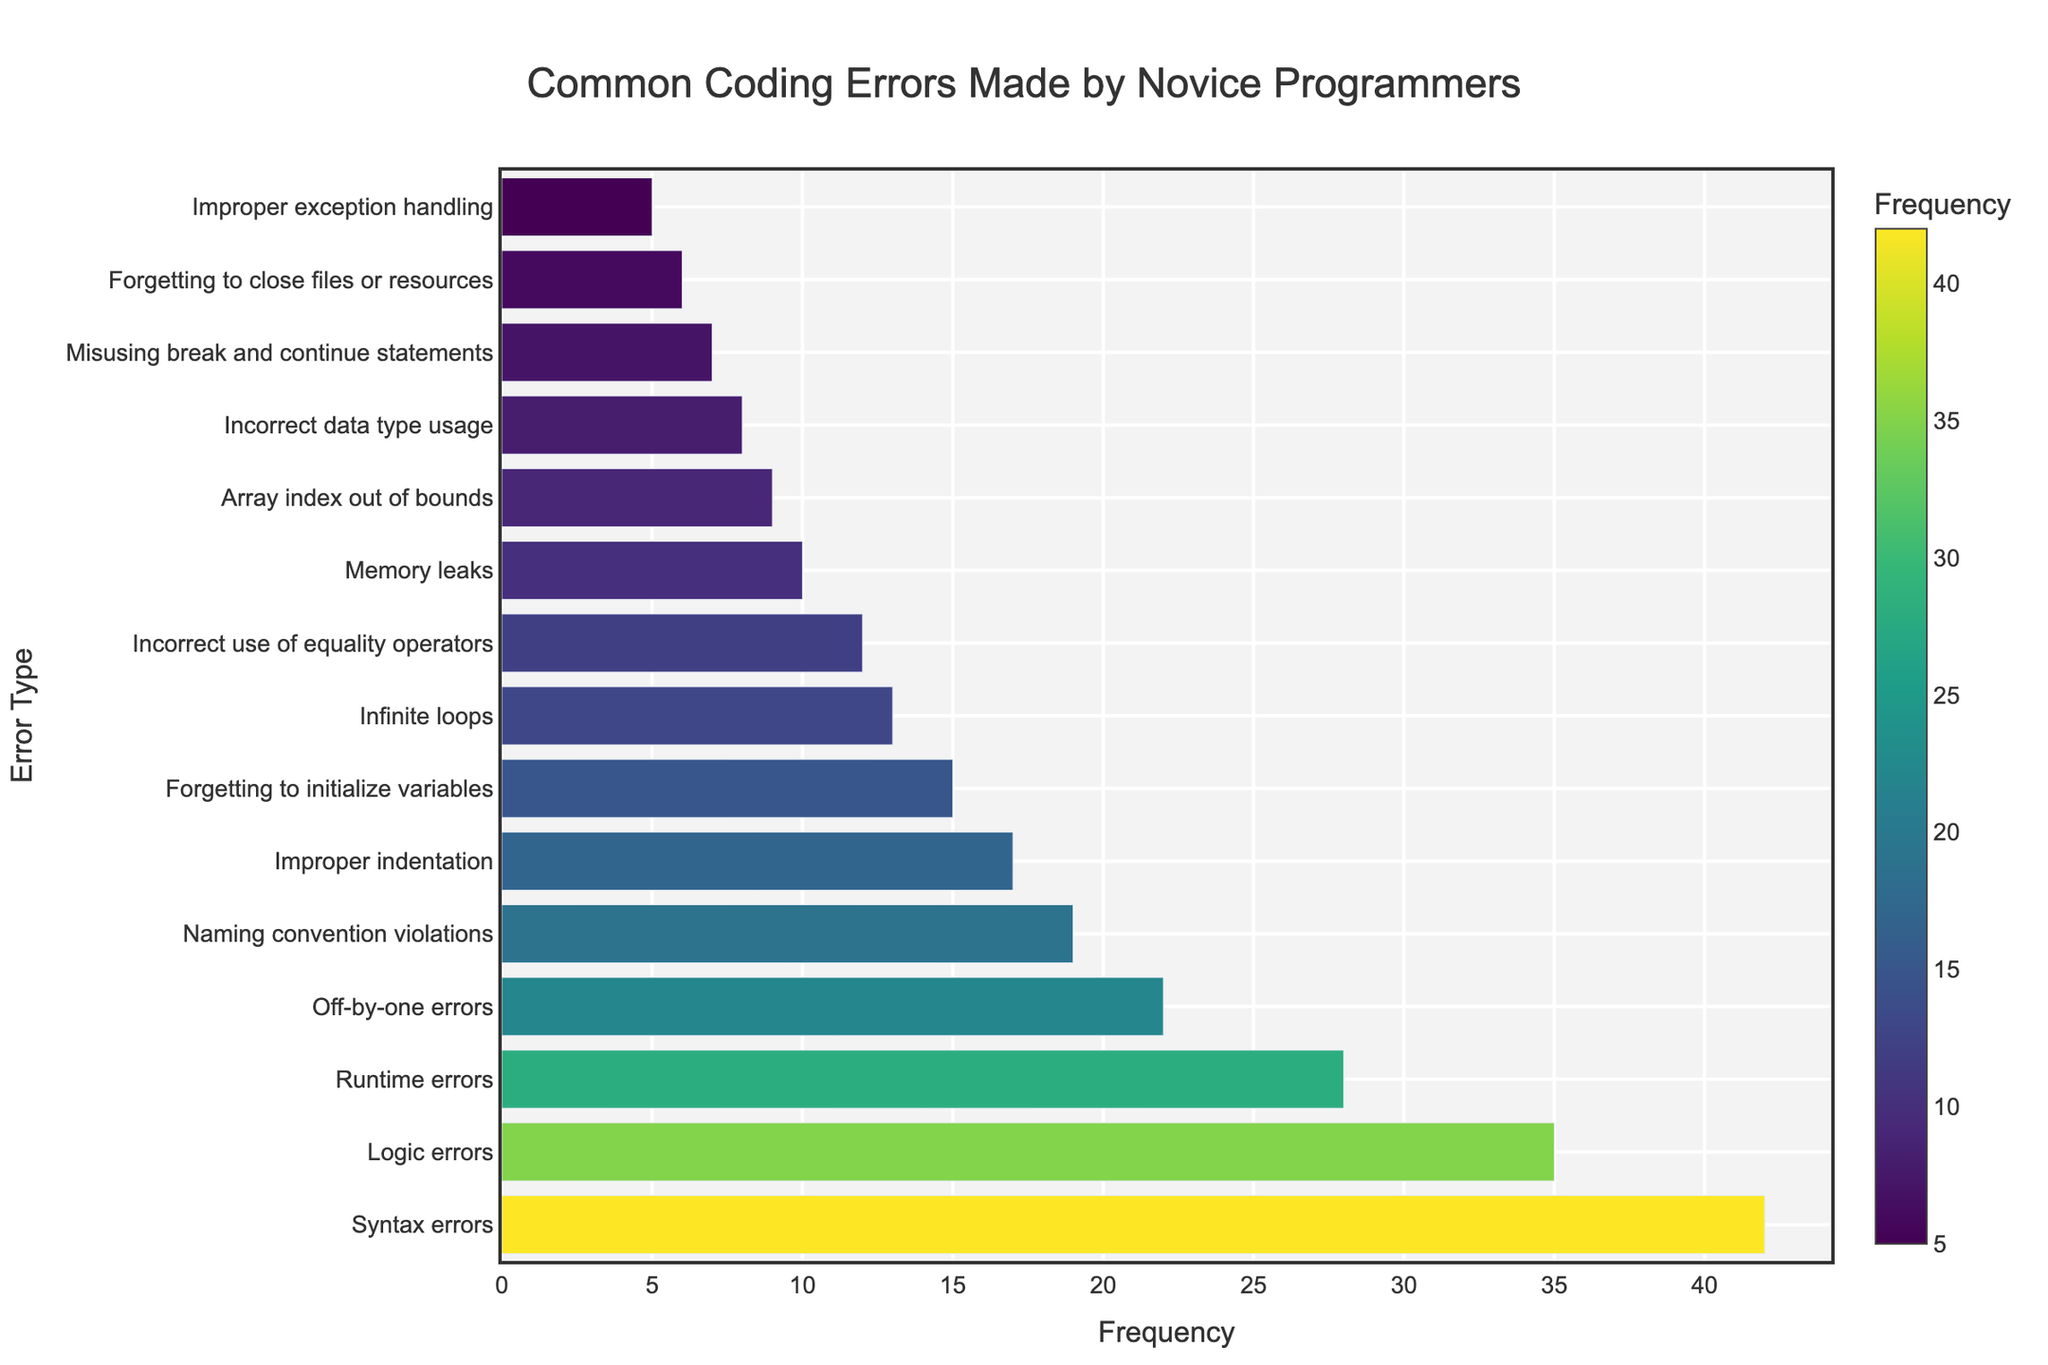What is the most common coding error made by novice programmers? The figure shows a bar chart listing different types of coding errors along with their frequencies. The longest bar represents the most common error, which is "Syntax errors" with a frequency of 42.
Answer: Syntax errors Which coding error has a lower frequency than "Runtime errors" but higher than "Naming convention violations"? The figure shows that "Off-by-one errors" has a frequency of 22, which is lower than "Runtime errors" (28) but higher than "Naming convention violations" (19).
Answer: Off-by-one errors What is the sum of the frequencies for "Logic errors" and "Improper indentation"? "Logic errors" have a frequency of 35 and "Improper indentation" has a frequency of 17. Adding these gives us 35 + 17 = 52.
Answer: 52 How much more frequent are "Syntax errors" compared to "Memory leaks"? "Syntax errors" have a frequency of 42 and "Memory leaks" have a frequency of 10. Subtracting these gives us 42 - 10 = 32.
Answer: 32 Are "Array index out of bounds" errors more or less common than "Infinite loops"? The frequency for "Array index out of bounds" is 9, while "Infinite loops" is 13. Therefore, "Array index out of bounds" errors are less common than "Infinite loops."
Answer: Less What is the average frequency of the errors that have more than 20 occurrences? Errors with frequencies greater than 20 are "Syntax errors" (42), "Logic errors" (35), "Runtime errors" (28), and "Off-by-one errors" (22). Sum these to get 42 + 35 + 28 + 22 = 127. There are 4 errors, so the average is 127 / 4 = 31.75.
Answer: 31.75 Which errors share the same color shading on the bar chart? The color shading represents similar frequency values. "Improper indentation" (17) and "Forgetting to initialize variables" (15) are close in frequency and would appear in similar color shading.
Answer: Improper indentation and Forgetting to initialize variables How many error types have frequencies under 10? Looking at the frequencies: "Array index out of bounds" (9), "Incorrect data type usage" (8), "Misusing break and continue statements" (7), "Forgetting to close files or resources" (6), and "Improper exception handling" (5). There are 5 error types under 10.
Answer: 5 